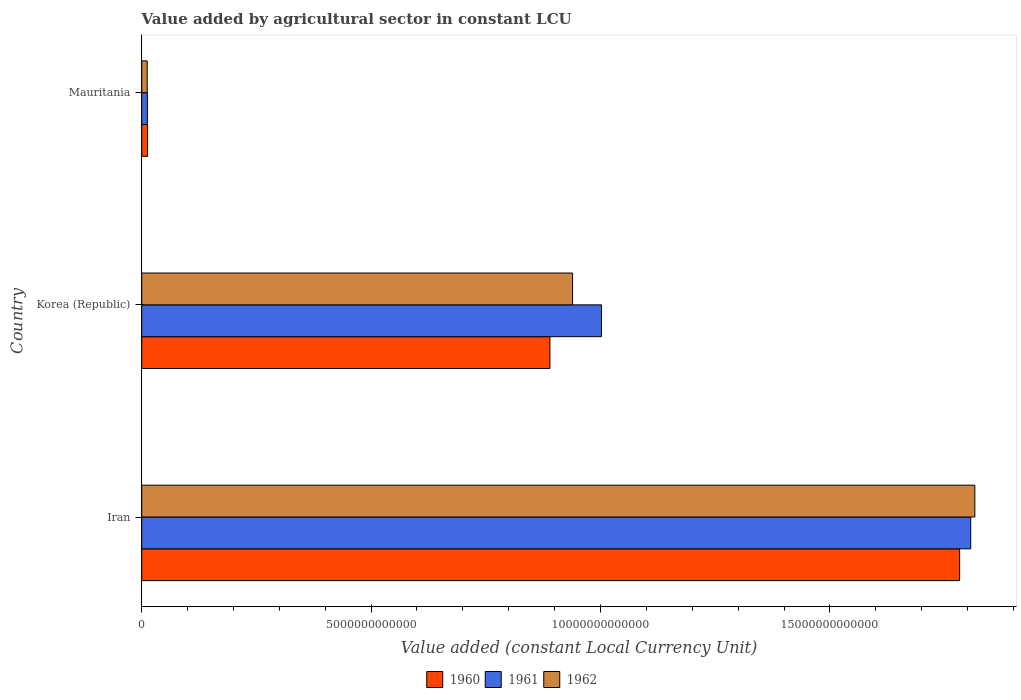How many different coloured bars are there?
Keep it short and to the point. 3. How many groups of bars are there?
Keep it short and to the point. 3. Are the number of bars on each tick of the Y-axis equal?
Keep it short and to the point. Yes. How many bars are there on the 2nd tick from the bottom?
Make the answer very short. 3. What is the label of the 3rd group of bars from the top?
Provide a succinct answer. Iran. What is the value added by agricultural sector in 1960 in Mauritania?
Your answer should be very brief. 1.27e+11. Across all countries, what is the maximum value added by agricultural sector in 1960?
Your answer should be compact. 1.78e+13. Across all countries, what is the minimum value added by agricultural sector in 1962?
Keep it short and to the point. 1.20e+11. In which country was the value added by agricultural sector in 1961 maximum?
Give a very brief answer. Iran. In which country was the value added by agricultural sector in 1962 minimum?
Give a very brief answer. Mauritania. What is the total value added by agricultural sector in 1960 in the graph?
Keep it short and to the point. 2.69e+13. What is the difference between the value added by agricultural sector in 1962 in Korea (Republic) and that in Mauritania?
Ensure brevity in your answer.  9.27e+12. What is the difference between the value added by agricultural sector in 1960 in Korea (Republic) and the value added by agricultural sector in 1962 in Iran?
Make the answer very short. -9.26e+12. What is the average value added by agricultural sector in 1962 per country?
Make the answer very short. 9.22e+12. What is the difference between the value added by agricultural sector in 1961 and value added by agricultural sector in 1960 in Korea (Republic)?
Ensure brevity in your answer.  1.12e+12. What is the ratio of the value added by agricultural sector in 1962 in Iran to that in Mauritania?
Give a very brief answer. 151.8. Is the difference between the value added by agricultural sector in 1961 in Korea (Republic) and Mauritania greater than the difference between the value added by agricultural sector in 1960 in Korea (Republic) and Mauritania?
Provide a succinct answer. Yes. What is the difference between the highest and the second highest value added by agricultural sector in 1960?
Your answer should be very brief. 8.93e+12. What is the difference between the highest and the lowest value added by agricultural sector in 1962?
Provide a succinct answer. 1.80e+13. What does the 1st bar from the top in Mauritania represents?
Offer a terse response. 1962. How many bars are there?
Ensure brevity in your answer.  9. Are all the bars in the graph horizontal?
Offer a terse response. Yes. What is the difference between two consecutive major ticks on the X-axis?
Provide a succinct answer. 5.00e+12. How many legend labels are there?
Give a very brief answer. 3. How are the legend labels stacked?
Your response must be concise. Horizontal. What is the title of the graph?
Make the answer very short. Value added by agricultural sector in constant LCU. What is the label or title of the X-axis?
Offer a very short reply. Value added (constant Local Currency Unit). What is the Value added (constant Local Currency Unit) in 1960 in Iran?
Provide a succinct answer. 1.78e+13. What is the Value added (constant Local Currency Unit) of 1961 in Iran?
Provide a short and direct response. 1.81e+13. What is the Value added (constant Local Currency Unit) in 1962 in Iran?
Give a very brief answer. 1.82e+13. What is the Value added (constant Local Currency Unit) in 1960 in Korea (Republic)?
Your answer should be very brief. 8.90e+12. What is the Value added (constant Local Currency Unit) of 1961 in Korea (Republic)?
Make the answer very short. 1.00e+13. What is the Value added (constant Local Currency Unit) of 1962 in Korea (Republic)?
Your answer should be compact. 9.39e+12. What is the Value added (constant Local Currency Unit) in 1960 in Mauritania?
Your response must be concise. 1.27e+11. What is the Value added (constant Local Currency Unit) of 1961 in Mauritania?
Give a very brief answer. 1.23e+11. What is the Value added (constant Local Currency Unit) in 1962 in Mauritania?
Offer a very short reply. 1.20e+11. Across all countries, what is the maximum Value added (constant Local Currency Unit) of 1960?
Make the answer very short. 1.78e+13. Across all countries, what is the maximum Value added (constant Local Currency Unit) in 1961?
Provide a succinct answer. 1.81e+13. Across all countries, what is the maximum Value added (constant Local Currency Unit) of 1962?
Make the answer very short. 1.82e+13. Across all countries, what is the minimum Value added (constant Local Currency Unit) in 1960?
Your answer should be very brief. 1.27e+11. Across all countries, what is the minimum Value added (constant Local Currency Unit) in 1961?
Your response must be concise. 1.23e+11. Across all countries, what is the minimum Value added (constant Local Currency Unit) in 1962?
Your answer should be compact. 1.20e+11. What is the total Value added (constant Local Currency Unit) of 1960 in the graph?
Your response must be concise. 2.69e+13. What is the total Value added (constant Local Currency Unit) of 1961 in the graph?
Ensure brevity in your answer.  2.82e+13. What is the total Value added (constant Local Currency Unit) of 1962 in the graph?
Ensure brevity in your answer.  2.77e+13. What is the difference between the Value added (constant Local Currency Unit) in 1960 in Iran and that in Korea (Republic)?
Keep it short and to the point. 8.93e+12. What is the difference between the Value added (constant Local Currency Unit) of 1961 in Iran and that in Korea (Republic)?
Make the answer very short. 8.05e+12. What is the difference between the Value added (constant Local Currency Unit) of 1962 in Iran and that in Korea (Republic)?
Provide a succinct answer. 8.77e+12. What is the difference between the Value added (constant Local Currency Unit) of 1960 in Iran and that in Mauritania?
Provide a succinct answer. 1.77e+13. What is the difference between the Value added (constant Local Currency Unit) in 1961 in Iran and that in Mauritania?
Offer a terse response. 1.79e+13. What is the difference between the Value added (constant Local Currency Unit) in 1962 in Iran and that in Mauritania?
Ensure brevity in your answer.  1.80e+13. What is the difference between the Value added (constant Local Currency Unit) in 1960 in Korea (Republic) and that in Mauritania?
Provide a short and direct response. 8.77e+12. What is the difference between the Value added (constant Local Currency Unit) in 1961 in Korea (Republic) and that in Mauritania?
Ensure brevity in your answer.  9.90e+12. What is the difference between the Value added (constant Local Currency Unit) in 1962 in Korea (Republic) and that in Mauritania?
Give a very brief answer. 9.27e+12. What is the difference between the Value added (constant Local Currency Unit) of 1960 in Iran and the Value added (constant Local Currency Unit) of 1961 in Korea (Republic)?
Provide a short and direct response. 7.81e+12. What is the difference between the Value added (constant Local Currency Unit) of 1960 in Iran and the Value added (constant Local Currency Unit) of 1962 in Korea (Republic)?
Keep it short and to the point. 8.44e+12. What is the difference between the Value added (constant Local Currency Unit) of 1961 in Iran and the Value added (constant Local Currency Unit) of 1962 in Korea (Republic)?
Provide a short and direct response. 8.68e+12. What is the difference between the Value added (constant Local Currency Unit) in 1960 in Iran and the Value added (constant Local Currency Unit) in 1961 in Mauritania?
Your response must be concise. 1.77e+13. What is the difference between the Value added (constant Local Currency Unit) in 1960 in Iran and the Value added (constant Local Currency Unit) in 1962 in Mauritania?
Ensure brevity in your answer.  1.77e+13. What is the difference between the Value added (constant Local Currency Unit) in 1961 in Iran and the Value added (constant Local Currency Unit) in 1962 in Mauritania?
Ensure brevity in your answer.  1.80e+13. What is the difference between the Value added (constant Local Currency Unit) of 1960 in Korea (Republic) and the Value added (constant Local Currency Unit) of 1961 in Mauritania?
Make the answer very short. 8.77e+12. What is the difference between the Value added (constant Local Currency Unit) of 1960 in Korea (Republic) and the Value added (constant Local Currency Unit) of 1962 in Mauritania?
Your response must be concise. 8.78e+12. What is the difference between the Value added (constant Local Currency Unit) in 1961 in Korea (Republic) and the Value added (constant Local Currency Unit) in 1962 in Mauritania?
Ensure brevity in your answer.  9.90e+12. What is the average Value added (constant Local Currency Unit) of 1960 per country?
Offer a terse response. 8.95e+12. What is the average Value added (constant Local Currency Unit) of 1961 per country?
Your response must be concise. 9.41e+12. What is the average Value added (constant Local Currency Unit) of 1962 per country?
Your response must be concise. 9.22e+12. What is the difference between the Value added (constant Local Currency Unit) of 1960 and Value added (constant Local Currency Unit) of 1961 in Iran?
Your response must be concise. -2.42e+11. What is the difference between the Value added (constant Local Currency Unit) in 1960 and Value added (constant Local Currency Unit) in 1962 in Iran?
Make the answer very short. -3.32e+11. What is the difference between the Value added (constant Local Currency Unit) of 1961 and Value added (constant Local Currency Unit) of 1962 in Iran?
Your answer should be compact. -8.95e+1. What is the difference between the Value added (constant Local Currency Unit) in 1960 and Value added (constant Local Currency Unit) in 1961 in Korea (Republic)?
Ensure brevity in your answer.  -1.12e+12. What is the difference between the Value added (constant Local Currency Unit) in 1960 and Value added (constant Local Currency Unit) in 1962 in Korea (Republic)?
Your response must be concise. -4.93e+11. What is the difference between the Value added (constant Local Currency Unit) in 1961 and Value added (constant Local Currency Unit) in 1962 in Korea (Republic)?
Your answer should be very brief. 6.31e+11. What is the difference between the Value added (constant Local Currency Unit) in 1960 and Value added (constant Local Currency Unit) in 1961 in Mauritania?
Your answer should be compact. 4.01e+09. What is the difference between the Value added (constant Local Currency Unit) in 1960 and Value added (constant Local Currency Unit) in 1962 in Mauritania?
Keep it short and to the point. 7.67e+09. What is the difference between the Value added (constant Local Currency Unit) of 1961 and Value added (constant Local Currency Unit) of 1962 in Mauritania?
Make the answer very short. 3.65e+09. What is the ratio of the Value added (constant Local Currency Unit) in 1960 in Iran to that in Korea (Republic)?
Ensure brevity in your answer.  2. What is the ratio of the Value added (constant Local Currency Unit) in 1961 in Iran to that in Korea (Republic)?
Offer a terse response. 1.8. What is the ratio of the Value added (constant Local Currency Unit) in 1962 in Iran to that in Korea (Republic)?
Your answer should be compact. 1.93. What is the ratio of the Value added (constant Local Currency Unit) of 1960 in Iran to that in Mauritania?
Your response must be concise. 140.05. What is the ratio of the Value added (constant Local Currency Unit) of 1961 in Iran to that in Mauritania?
Ensure brevity in your answer.  146.57. What is the ratio of the Value added (constant Local Currency Unit) in 1962 in Iran to that in Mauritania?
Make the answer very short. 151.8. What is the ratio of the Value added (constant Local Currency Unit) in 1960 in Korea (Republic) to that in Mauritania?
Provide a short and direct response. 69.9. What is the ratio of the Value added (constant Local Currency Unit) of 1961 in Korea (Republic) to that in Mauritania?
Provide a short and direct response. 81.29. What is the ratio of the Value added (constant Local Currency Unit) in 1962 in Korea (Republic) to that in Mauritania?
Provide a short and direct response. 78.51. What is the difference between the highest and the second highest Value added (constant Local Currency Unit) in 1960?
Your answer should be very brief. 8.93e+12. What is the difference between the highest and the second highest Value added (constant Local Currency Unit) in 1961?
Give a very brief answer. 8.05e+12. What is the difference between the highest and the second highest Value added (constant Local Currency Unit) of 1962?
Your answer should be very brief. 8.77e+12. What is the difference between the highest and the lowest Value added (constant Local Currency Unit) of 1960?
Keep it short and to the point. 1.77e+13. What is the difference between the highest and the lowest Value added (constant Local Currency Unit) in 1961?
Keep it short and to the point. 1.79e+13. What is the difference between the highest and the lowest Value added (constant Local Currency Unit) in 1962?
Your answer should be compact. 1.80e+13. 